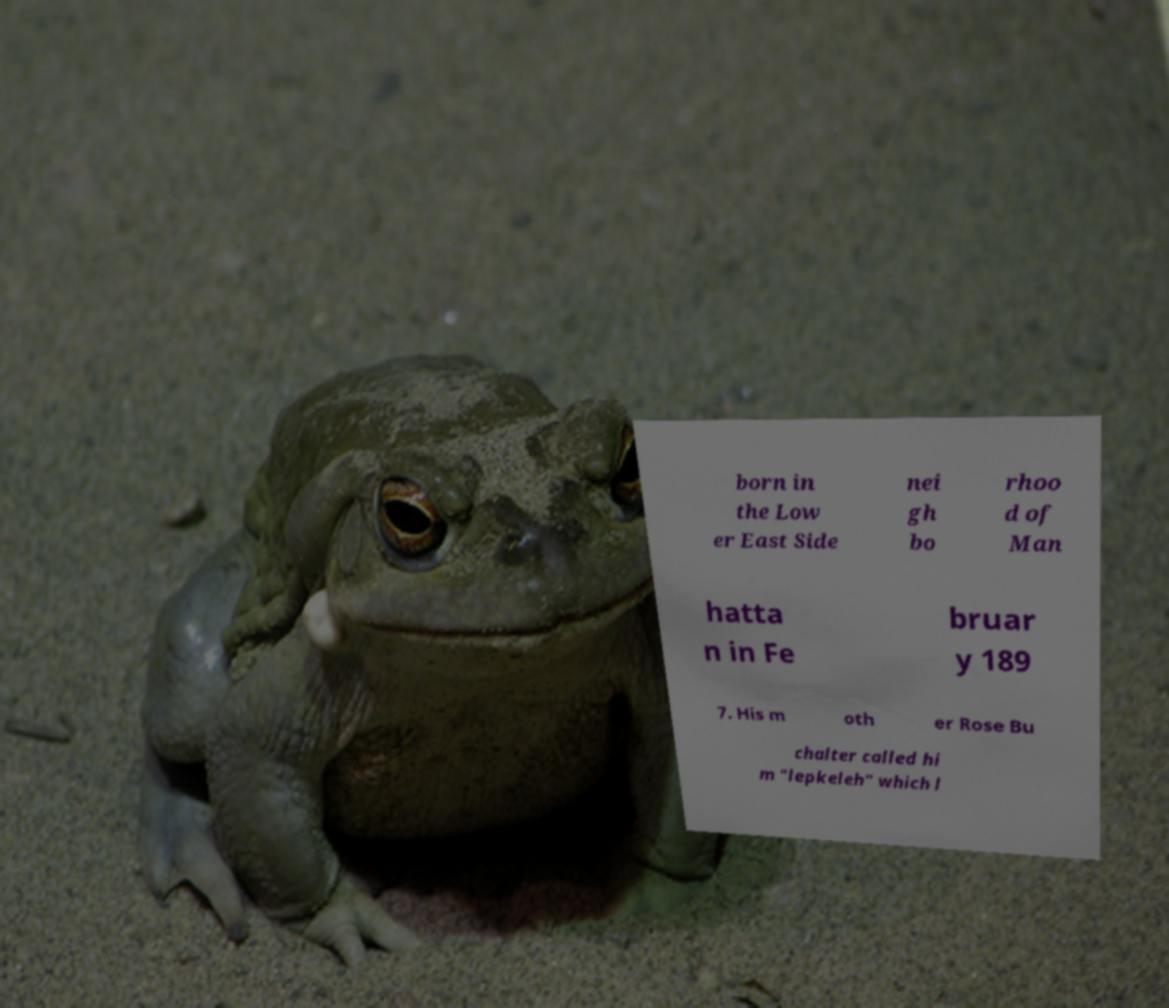Please identify and transcribe the text found in this image. born in the Low er East Side nei gh bo rhoo d of Man hatta n in Fe bruar y 189 7. His m oth er Rose Bu chalter called hi m "lepkeleh" which l 